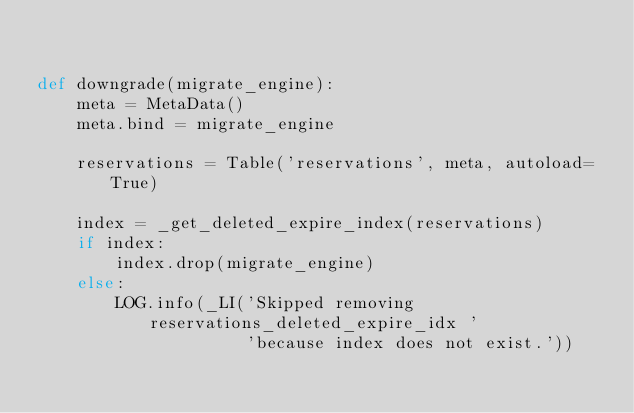<code> <loc_0><loc_0><loc_500><loc_500><_Python_>

def downgrade(migrate_engine):
    meta = MetaData()
    meta.bind = migrate_engine

    reservations = Table('reservations', meta, autoload=True)

    index = _get_deleted_expire_index(reservations)
    if index:
        index.drop(migrate_engine)
    else:
        LOG.info(_LI('Skipped removing reservations_deleted_expire_idx '
                     'because index does not exist.'))
</code> 